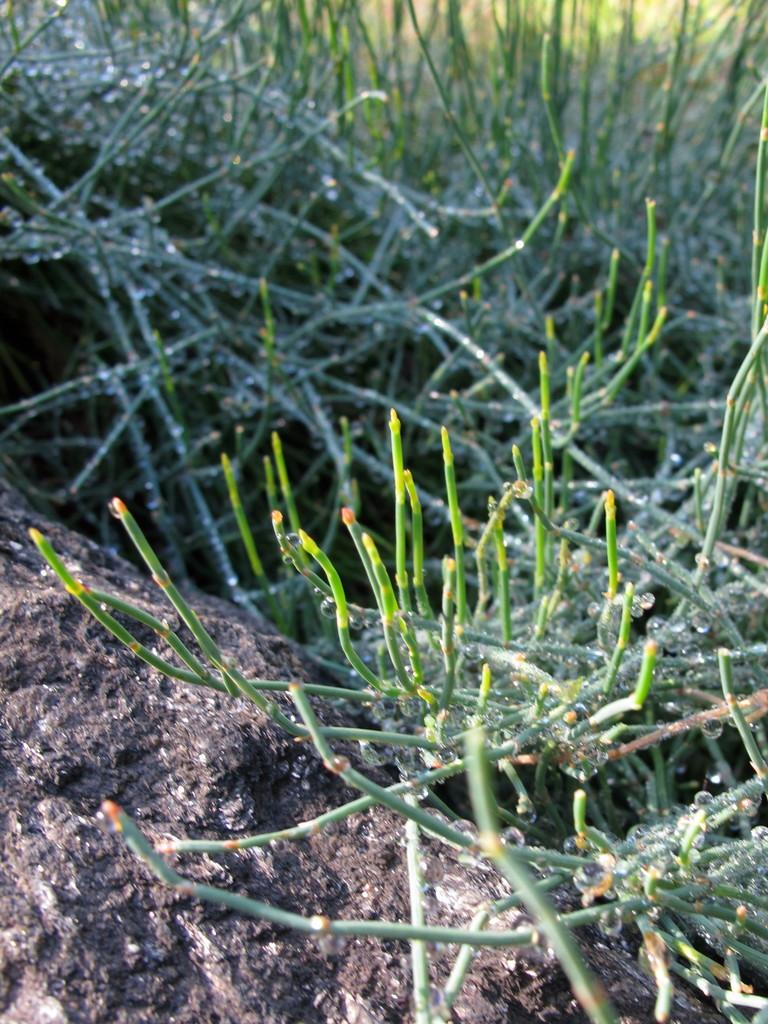What is the main subject in the image? There is a rock in the image. What else can be seen in the image besides the rock? There are plants in the image. How many letters are visible on the rock in the image? There are no letters visible on the rock in the image. What type of wing can be seen on the plants in the image? There are no wings present in the image, as it features a rock and plants, not any creatures with wings. 